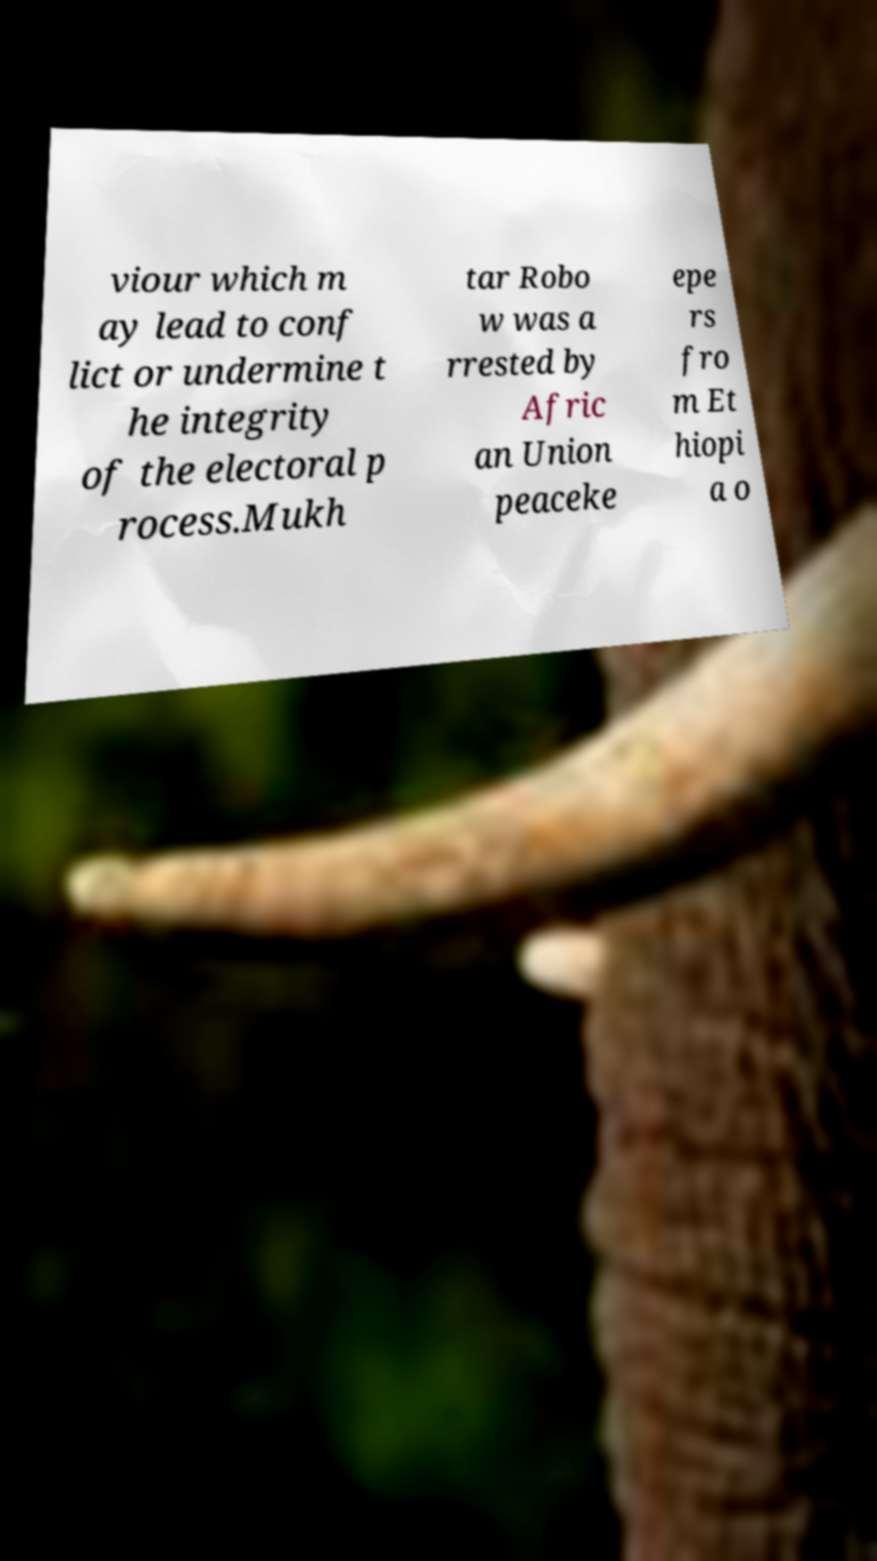Please read and relay the text visible in this image. What does it say? viour which m ay lead to conf lict or undermine t he integrity of the electoral p rocess.Mukh tar Robo w was a rrested by Afric an Union peaceke epe rs fro m Et hiopi a o 